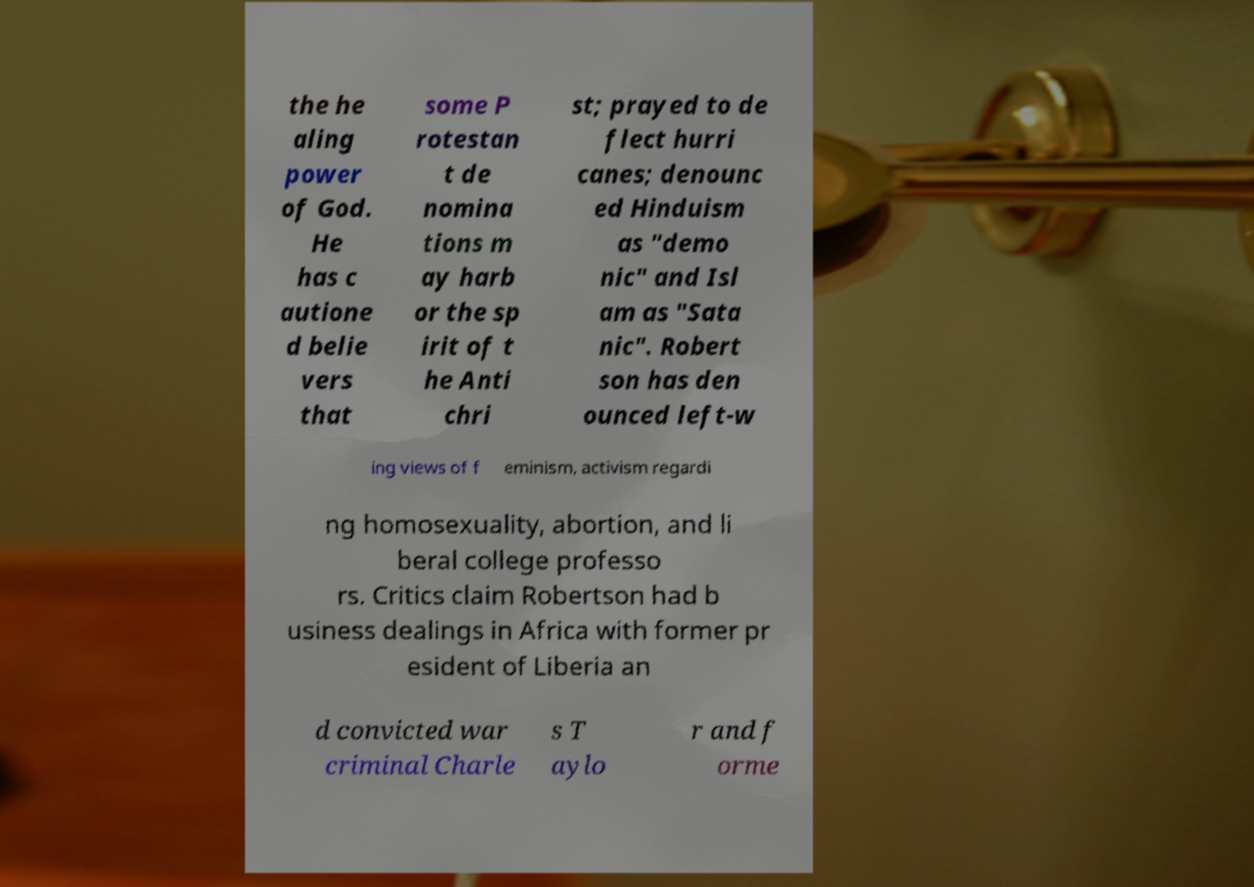There's text embedded in this image that I need extracted. Can you transcribe it verbatim? the he aling power of God. He has c autione d belie vers that some P rotestan t de nomina tions m ay harb or the sp irit of t he Anti chri st; prayed to de flect hurri canes; denounc ed Hinduism as "demo nic" and Isl am as "Sata nic". Robert son has den ounced left-w ing views of f eminism, activism regardi ng homosexuality, abortion, and li beral college professo rs. Critics claim Robertson had b usiness dealings in Africa with former pr esident of Liberia an d convicted war criminal Charle s T aylo r and f orme 